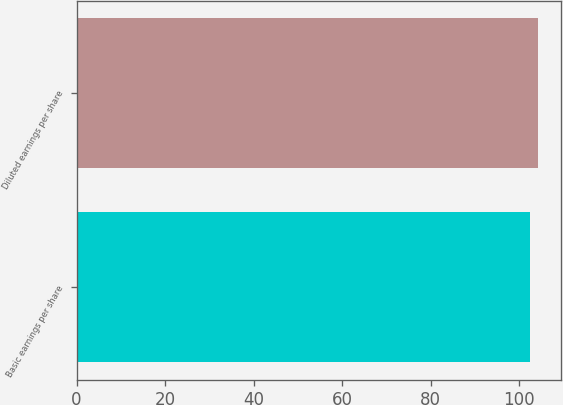<chart> <loc_0><loc_0><loc_500><loc_500><bar_chart><fcel>Basic earnings per share<fcel>Diluted earnings per share<nl><fcel>102.5<fcel>104.3<nl></chart> 